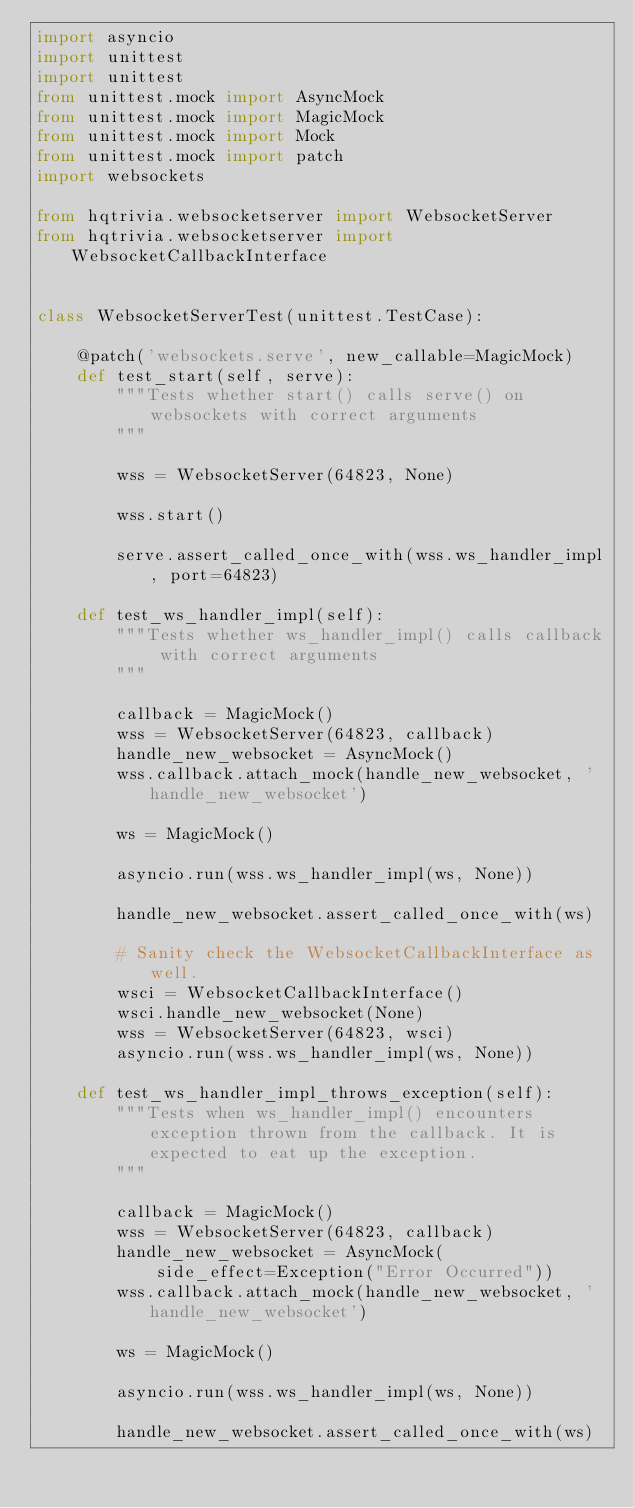<code> <loc_0><loc_0><loc_500><loc_500><_Python_>import asyncio
import unittest
import unittest
from unittest.mock import AsyncMock
from unittest.mock import MagicMock
from unittest.mock import Mock
from unittest.mock import patch
import websockets

from hqtrivia.websocketserver import WebsocketServer
from hqtrivia.websocketserver import WebsocketCallbackInterface


class WebsocketServerTest(unittest.TestCase):

    @patch('websockets.serve', new_callable=MagicMock)
    def test_start(self, serve):
        """Tests whether start() calls serve() on websockets with correct arguments
        """

        wss = WebsocketServer(64823, None)

        wss.start()

        serve.assert_called_once_with(wss.ws_handler_impl, port=64823)

    def test_ws_handler_impl(self):
        """Tests whether ws_handler_impl() calls callback with correct arguments
        """

        callback = MagicMock()
        wss = WebsocketServer(64823, callback)
        handle_new_websocket = AsyncMock()
        wss.callback.attach_mock(handle_new_websocket, 'handle_new_websocket')

        ws = MagicMock()

        asyncio.run(wss.ws_handler_impl(ws, None))

        handle_new_websocket.assert_called_once_with(ws)

        # Sanity check the WebsocketCallbackInterface as well.
        wsci = WebsocketCallbackInterface()
        wsci.handle_new_websocket(None)
        wss = WebsocketServer(64823, wsci)
        asyncio.run(wss.ws_handler_impl(ws, None))

    def test_ws_handler_impl_throws_exception(self):
        """Tests when ws_handler_impl() encounters exception thrown from the callback. It is expected to eat up the exception.
        """

        callback = MagicMock()
        wss = WebsocketServer(64823, callback)
        handle_new_websocket = AsyncMock(
            side_effect=Exception("Error Occurred"))
        wss.callback.attach_mock(handle_new_websocket, 'handle_new_websocket')

        ws = MagicMock()

        asyncio.run(wss.ws_handler_impl(ws, None))

        handle_new_websocket.assert_called_once_with(ws)
</code> 